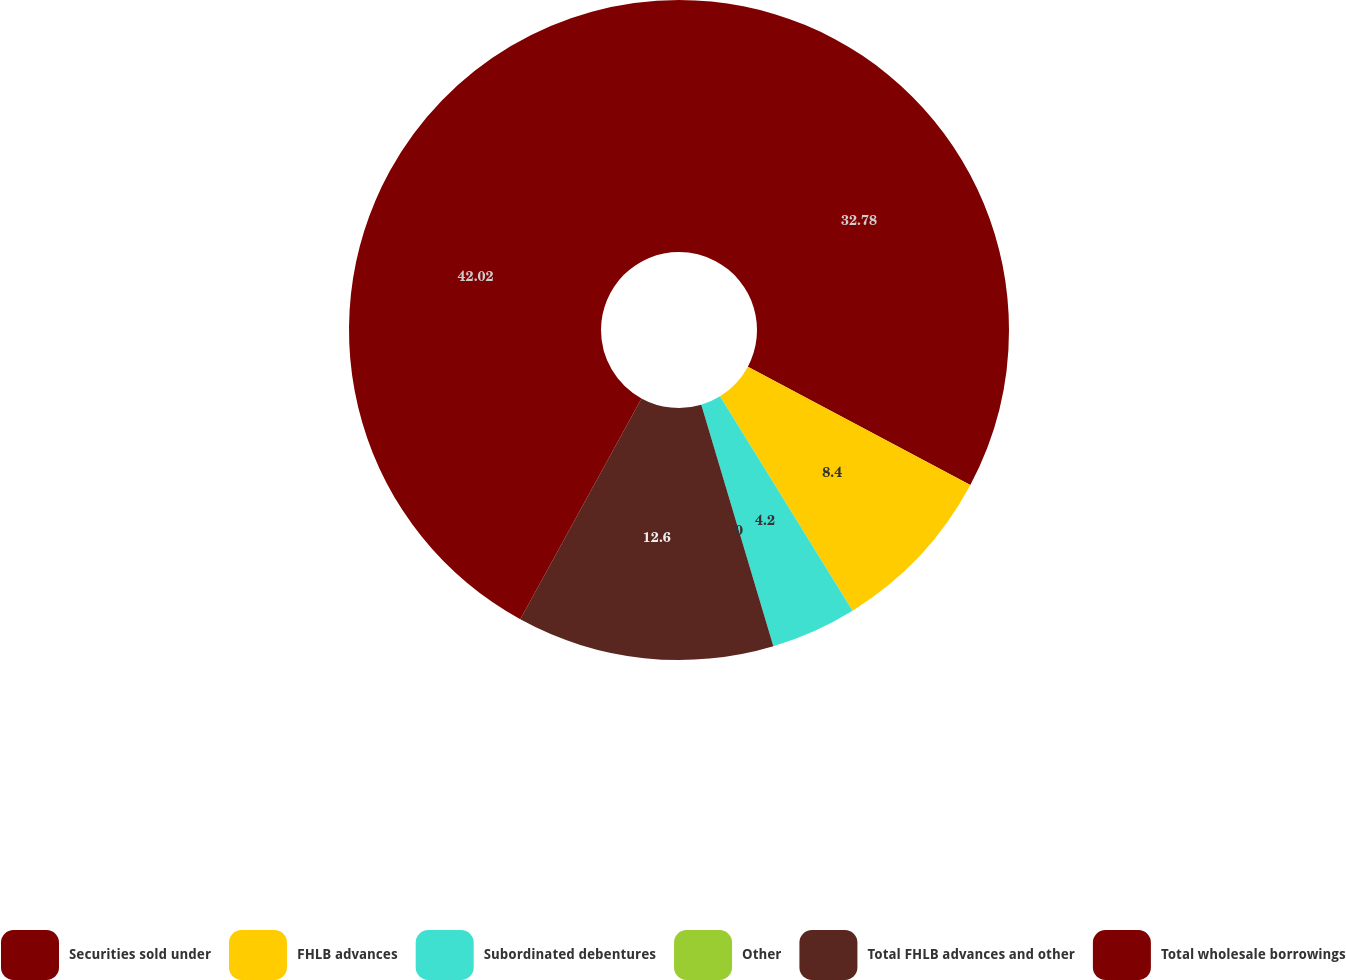<chart> <loc_0><loc_0><loc_500><loc_500><pie_chart><fcel>Securities sold under<fcel>FHLB advances<fcel>Subordinated debentures<fcel>Other<fcel>Total FHLB advances and other<fcel>Total wholesale borrowings<nl><fcel>32.78%<fcel>8.4%<fcel>4.2%<fcel>0.0%<fcel>12.6%<fcel>42.01%<nl></chart> 